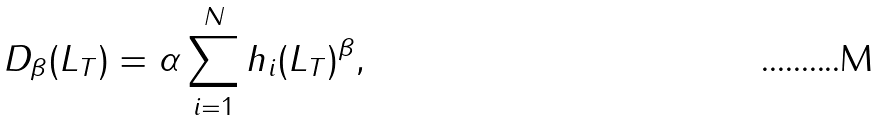Convert formula to latex. <formula><loc_0><loc_0><loc_500><loc_500>D _ { \beta } ( L _ { T } ) = \alpha \sum _ { i = 1 } ^ { N } h _ { i } ( L _ { T } ) ^ { \beta } ,</formula> 